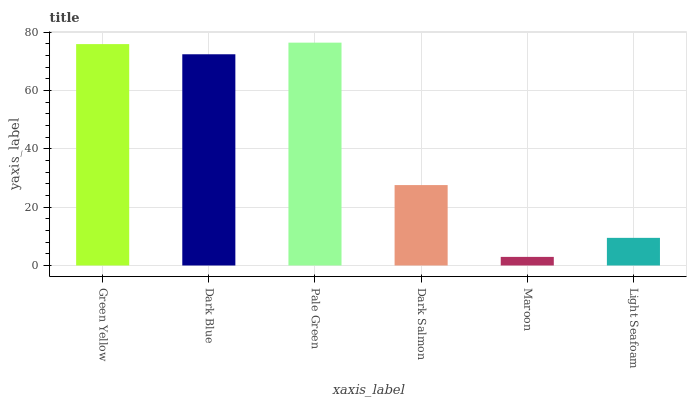Is Maroon the minimum?
Answer yes or no. Yes. Is Pale Green the maximum?
Answer yes or no. Yes. Is Dark Blue the minimum?
Answer yes or no. No. Is Dark Blue the maximum?
Answer yes or no. No. Is Green Yellow greater than Dark Blue?
Answer yes or no. Yes. Is Dark Blue less than Green Yellow?
Answer yes or no. Yes. Is Dark Blue greater than Green Yellow?
Answer yes or no. No. Is Green Yellow less than Dark Blue?
Answer yes or no. No. Is Dark Blue the high median?
Answer yes or no. Yes. Is Dark Salmon the low median?
Answer yes or no. Yes. Is Pale Green the high median?
Answer yes or no. No. Is Dark Blue the low median?
Answer yes or no. No. 